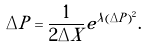Convert formula to latex. <formula><loc_0><loc_0><loc_500><loc_500>\Delta P = \frac { 1 } { 2 \Delta X } e ^ { \lambda ( \Delta P ) ^ { 2 } } .</formula> 